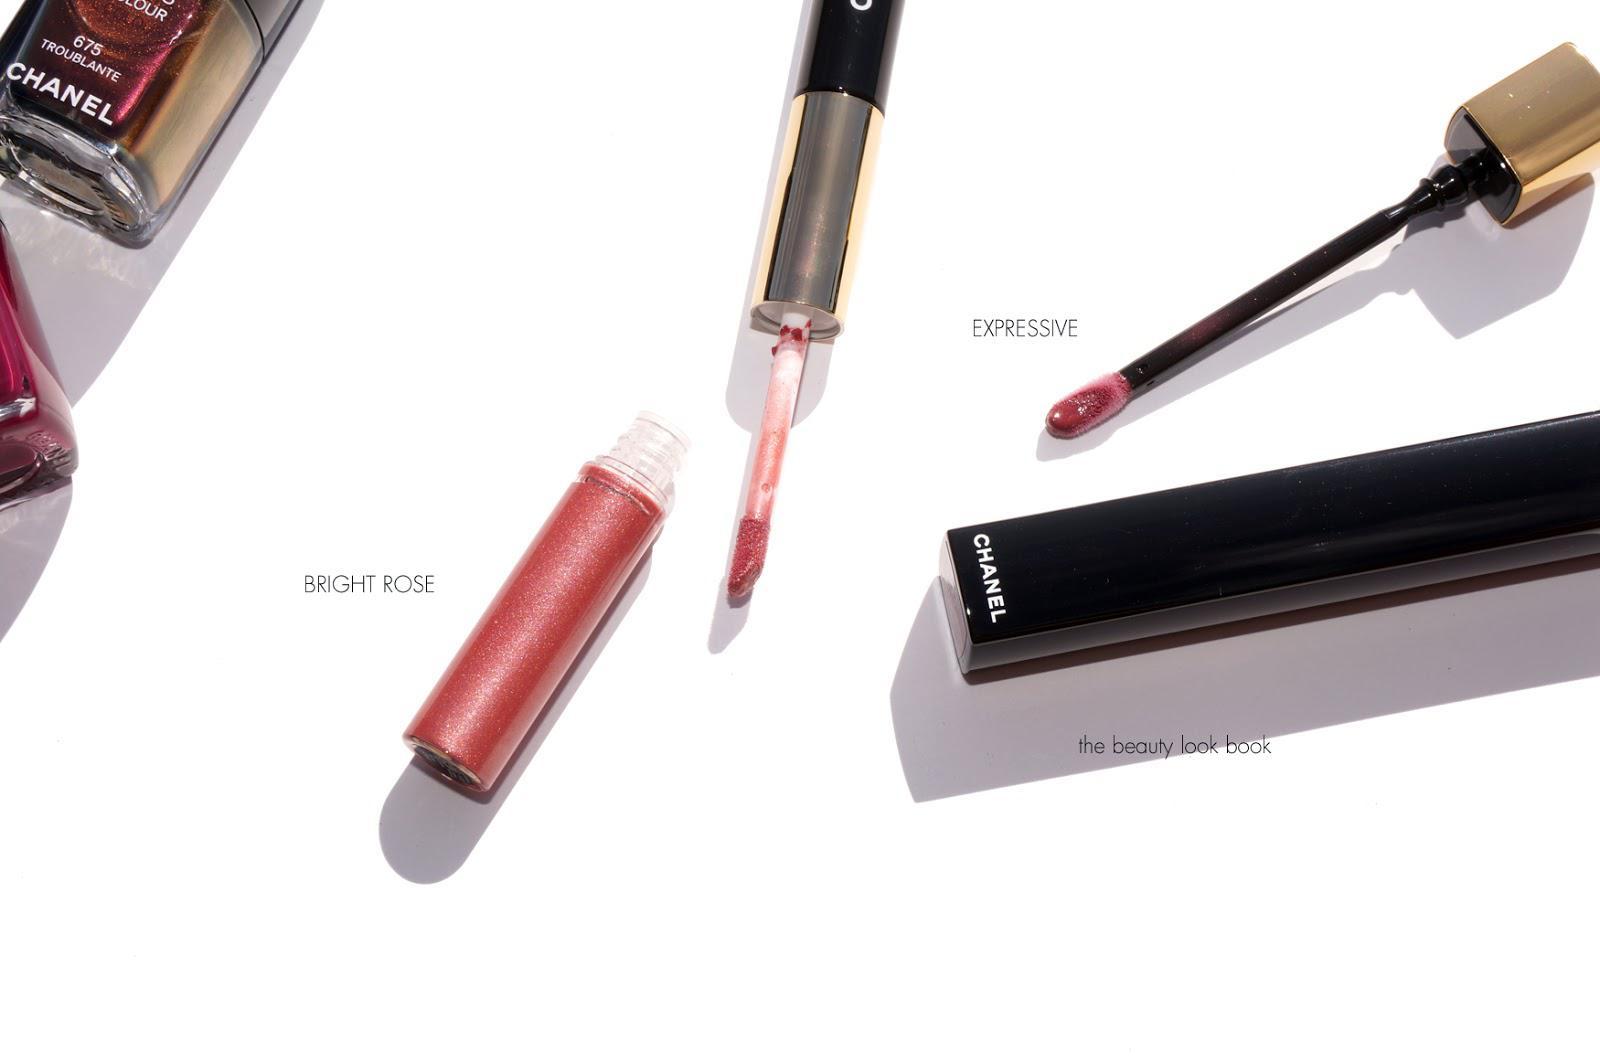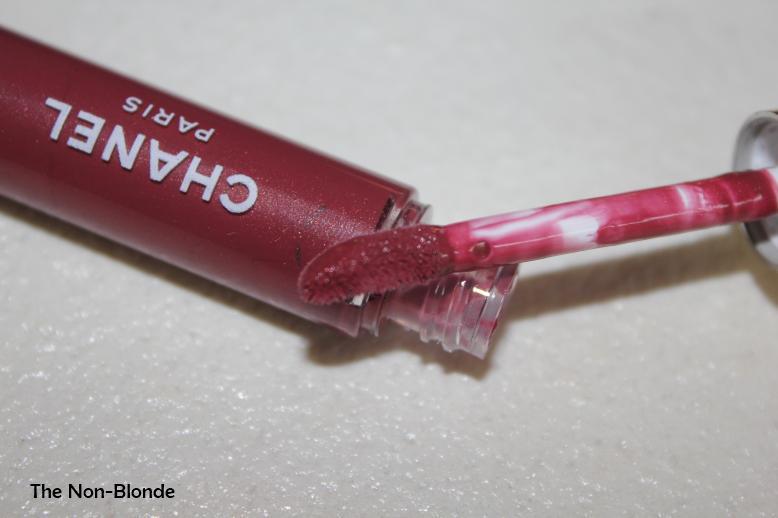The first image is the image on the left, the second image is the image on the right. Evaluate the accuracy of this statement regarding the images: "Left image contains one lipstick with its applicator resting atop its base, and the right image shows one lipstick with its cap on.". Is it true? Answer yes or no. No. The first image is the image on the left, the second image is the image on the right. For the images displayed, is the sentence "There are two tubes of lipstick, and one of them is open while the other one is closed." factually correct? Answer yes or no. No. 